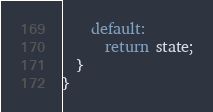<code> <loc_0><loc_0><loc_500><loc_500><_JavaScript_>    default:
      return state;
  }
}
</code> 